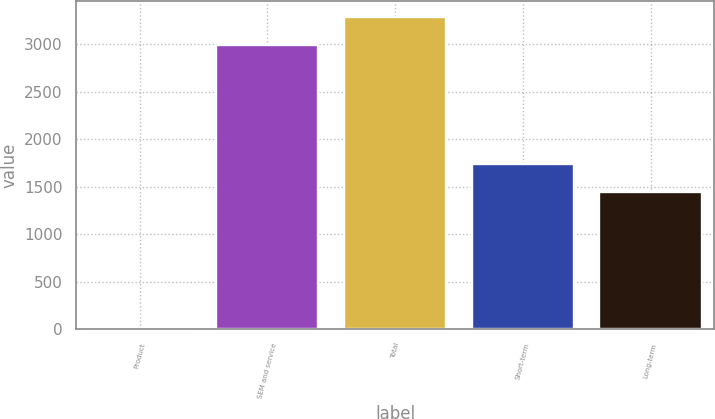Convert chart to OTSL. <chart><loc_0><loc_0><loc_500><loc_500><bar_chart><fcel>Product<fcel>SEM and service<fcel>Total<fcel>Short-term<fcel>Long-term<nl><fcel>15.7<fcel>2993.8<fcel>3293.18<fcel>1745.58<fcel>1446.2<nl></chart> 